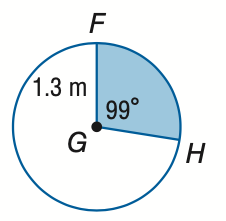Question: Find the area of the shaded sector. Round to the nearest tenth.
Choices:
A. 1.5
B. 2.2
C. 3.8
D. 5.3
Answer with the letter. Answer: A 